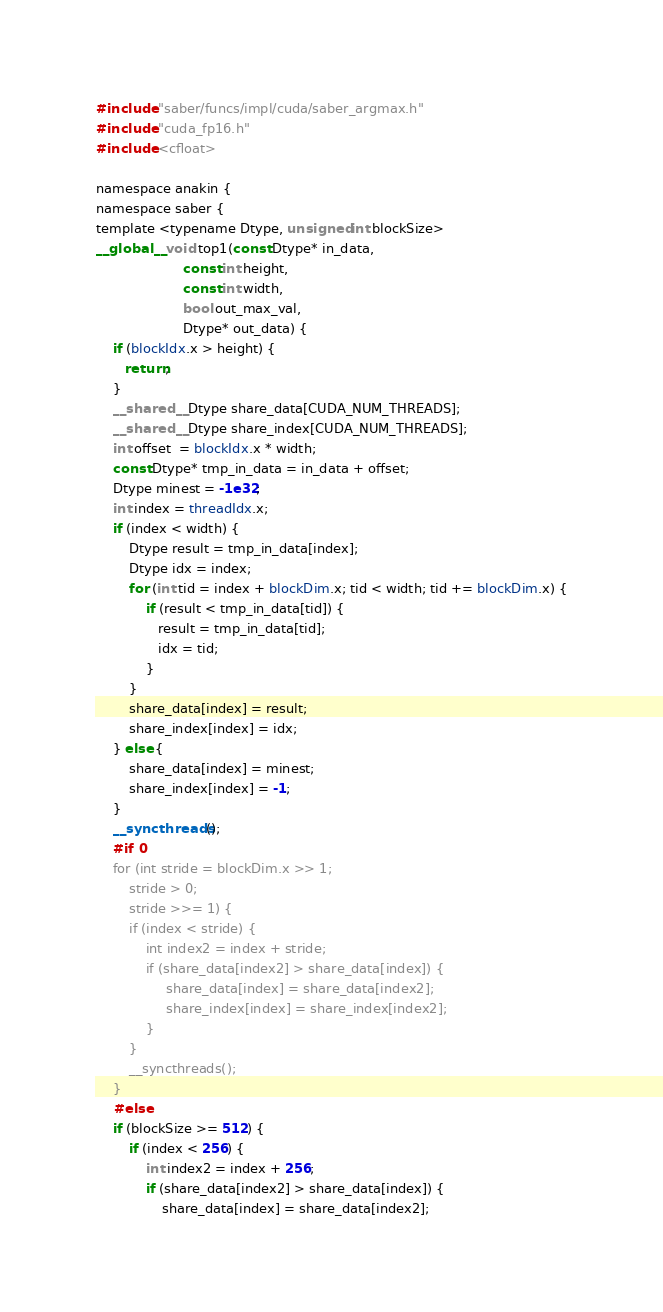Convert code to text. <code><loc_0><loc_0><loc_500><loc_500><_Cuda_>#include "saber/funcs/impl/cuda/saber_argmax.h"
#include "cuda_fp16.h"
#include <cfloat>

namespace anakin {
namespace saber {
template <typename Dtype, unsigned int blockSize>
__global__ void top1(const Dtype* in_data,
                     const int height,
                     const int width,
                     bool out_max_val,
                     Dtype* out_data) {
    if (blockIdx.x > height) {
       return;
    }
    __shared__ Dtype share_data[CUDA_NUM_THREADS];
    __shared__ Dtype share_index[CUDA_NUM_THREADS];
    int offset  = blockIdx.x * width;
    const Dtype* tmp_in_data = in_data + offset;
    Dtype minest = -1e32;
    int index = threadIdx.x;
    if (index < width) {
        Dtype result = tmp_in_data[index];
        Dtype idx = index;
        for (int tid = index + blockDim.x; tid < width; tid += blockDim.x) {
            if (result < tmp_in_data[tid]) {
               result = tmp_in_data[tid];
               idx = tid;
            }
        }
        share_data[index] = result;
        share_index[index] = idx;
    } else {
        share_data[index] = minest;
        share_index[index] = -1;
    }
    __syncthreads();
    #if 0
    for (int stride = blockDim.x >> 1;
        stride > 0;
        stride >>= 1) {
        if (index < stride) {
            int index2 = index + stride;
            if (share_data[index2] > share_data[index]) {
                 share_data[index] = share_data[index2];
                 share_index[index] = share_index[index2];
            }
        }
        __syncthreads();
    }
    #else
    if (blockSize >= 512) {
        if (index < 256) {
            int index2 = index + 256;
            if (share_data[index2] > share_data[index]) {
                share_data[index] = share_data[index2];</code> 